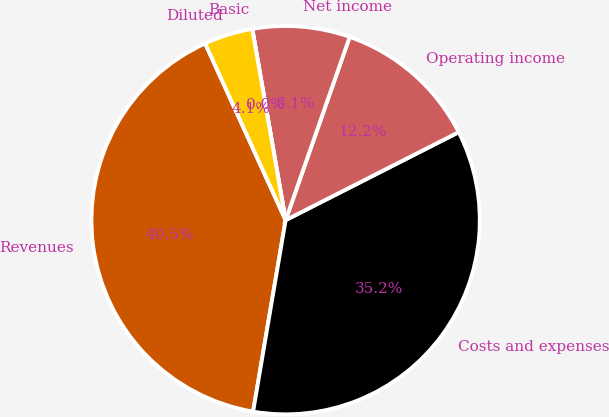Convert chart. <chart><loc_0><loc_0><loc_500><loc_500><pie_chart><fcel>Revenues<fcel>Costs and expenses<fcel>Operating income<fcel>Net income<fcel>Basic<fcel>Diluted<nl><fcel>40.52%<fcel>35.16%<fcel>12.16%<fcel>8.1%<fcel>0.0%<fcel>4.05%<nl></chart> 